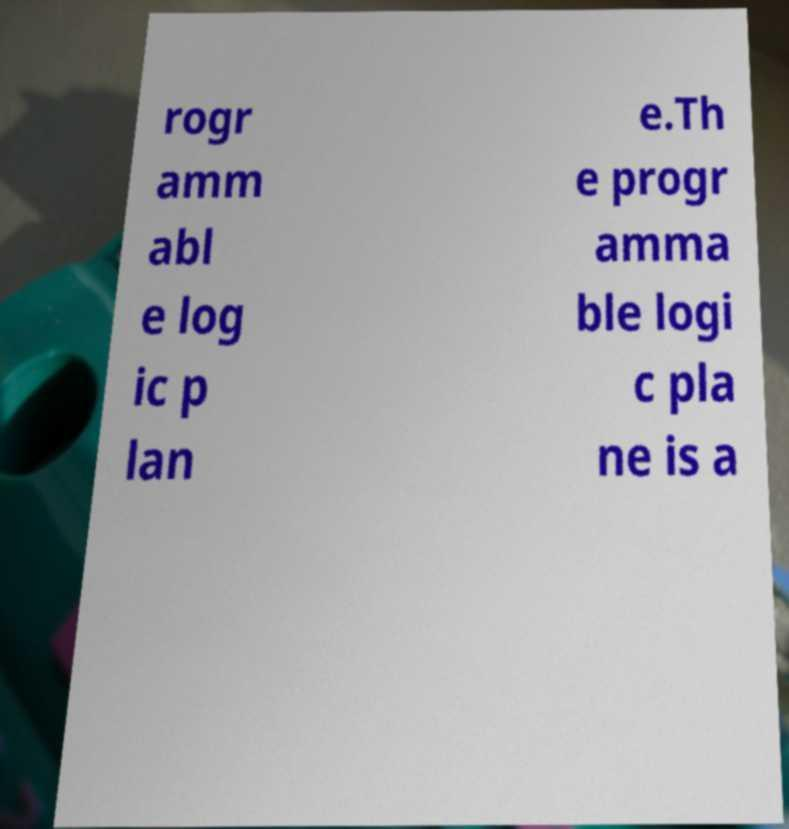Could you extract and type out the text from this image? rogr amm abl e log ic p lan e.Th e progr amma ble logi c pla ne is a 